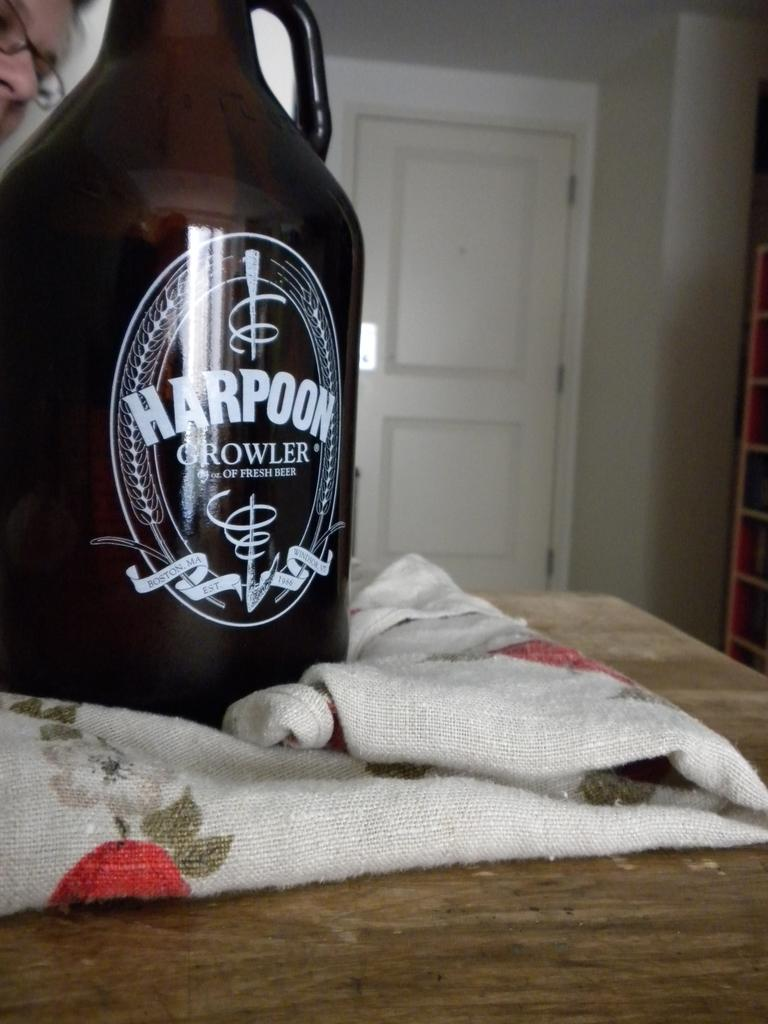<image>
Share a concise interpretation of the image provided. A harpoon Growler jug sits on a cloth on a table 